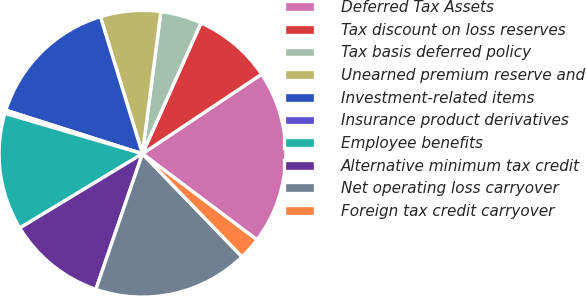Convert chart. <chart><loc_0><loc_0><loc_500><loc_500><pie_chart><fcel>Deferred Tax Assets<fcel>Tax discount on loss reserves<fcel>Tax basis deferred policy<fcel>Unearned premium reserve and<fcel>Investment-related items<fcel>Insurance product derivatives<fcel>Employee benefits<fcel>Alternative minimum tax credit<fcel>Net operating loss carryover<fcel>Foreign tax credit carryover<nl><fcel>19.63%<fcel>8.93%<fcel>4.65%<fcel>6.79%<fcel>15.35%<fcel>0.37%<fcel>13.21%<fcel>11.07%<fcel>17.49%<fcel>2.51%<nl></chart> 